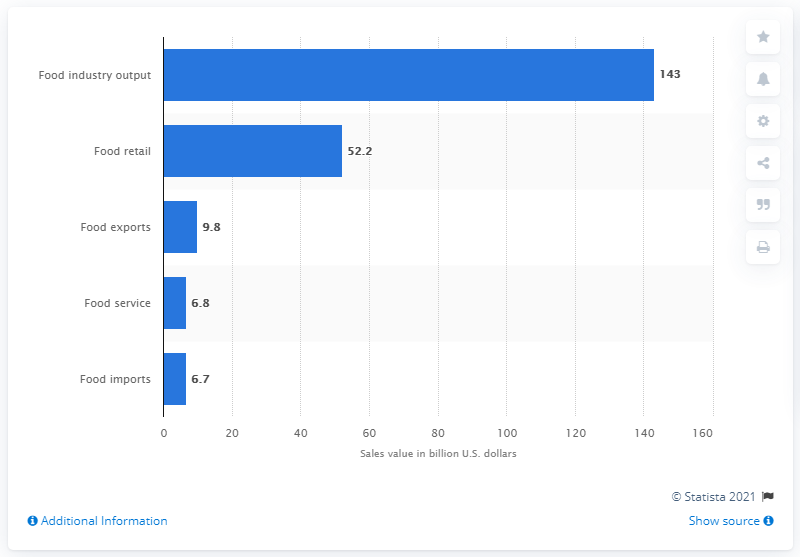Give some essential details in this illustration. According to data from 2018, the total amount of money spent on food retail sales in South Africa was 52.2 billion. In 2018, the value of the food service channel in South Africa was 6.8 billion dollars. 